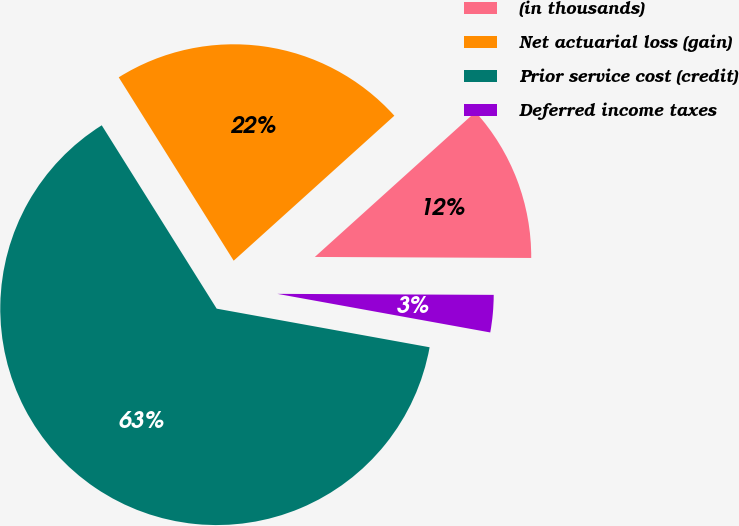Convert chart to OTSL. <chart><loc_0><loc_0><loc_500><loc_500><pie_chart><fcel>(in thousands)<fcel>Net actuarial loss (gain)<fcel>Prior service cost (credit)<fcel>Deferred income taxes<nl><fcel>11.76%<fcel>22.23%<fcel>63.24%<fcel>2.78%<nl></chart> 